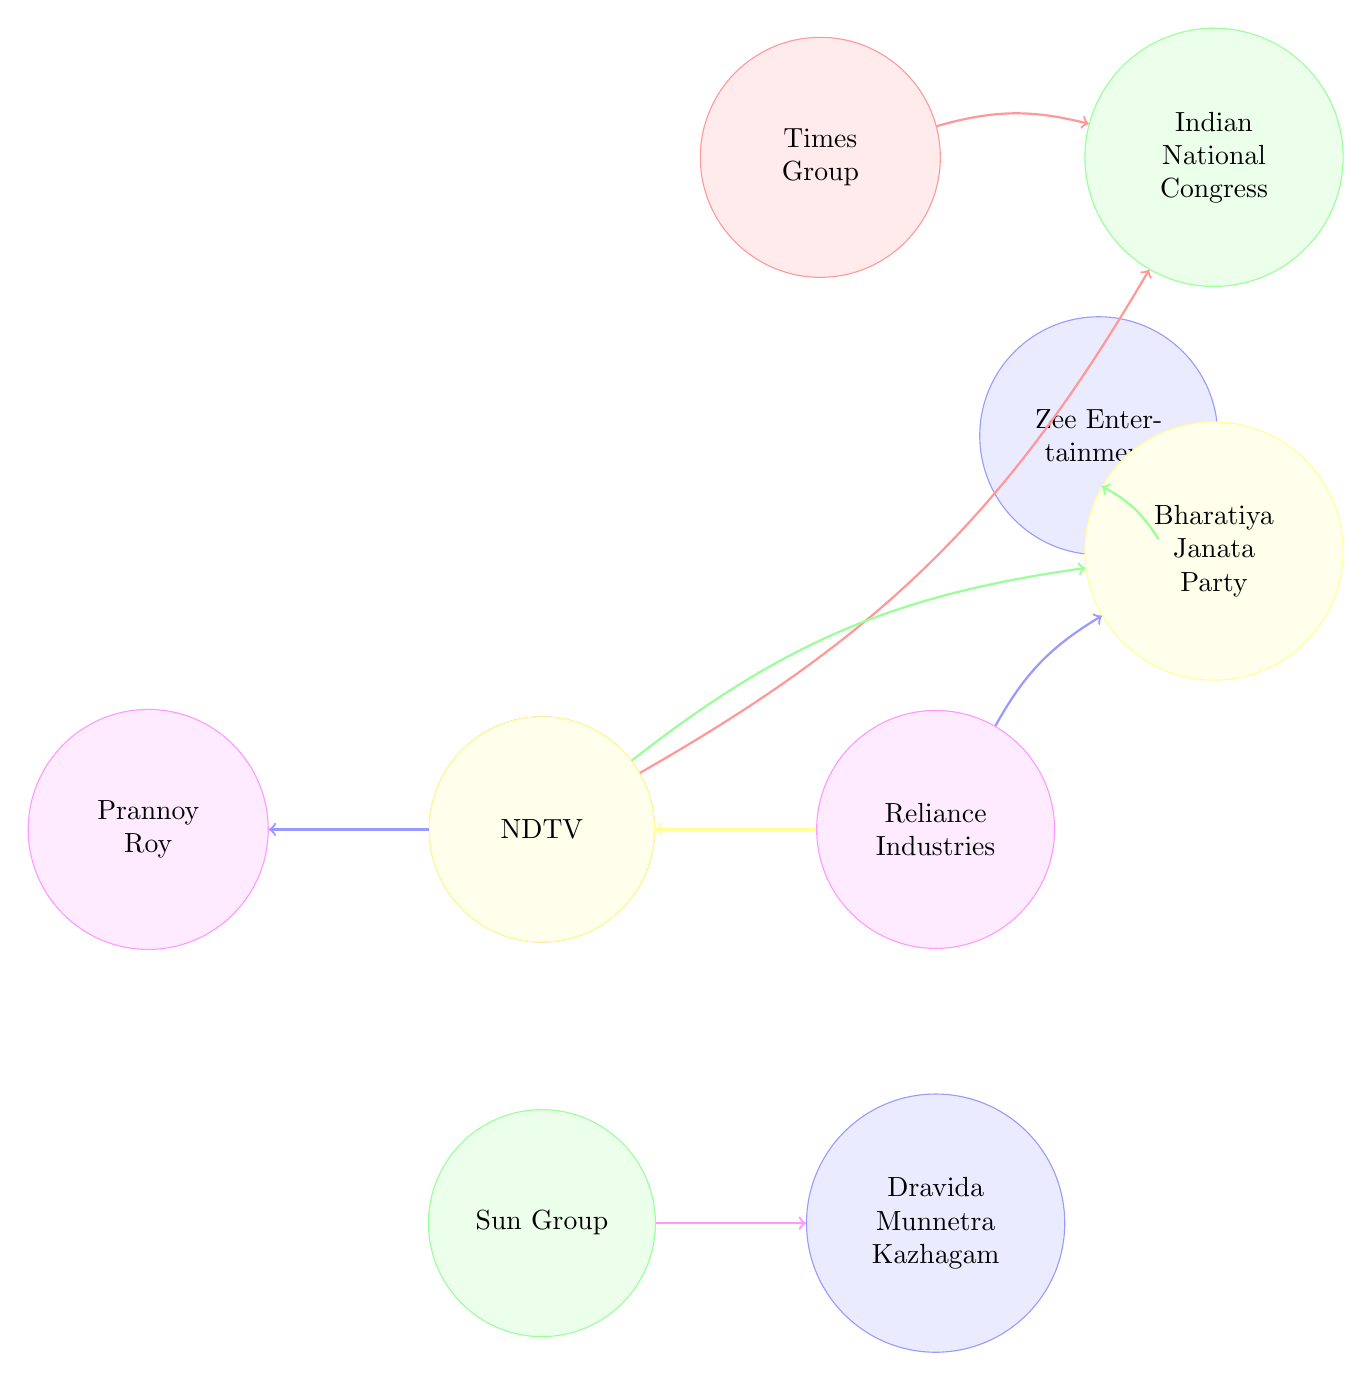What are the total number of nodes in the diagram? The diagram contains ten nodes: Times Group, Indian National Congress, Zee Entertainment, Bharatiya Janata Party, Reliance Industries, Network18, Sun Group, Dravida Munnetra Kazhagam, NDTV, and Prannoy Roy.
Answer: 10 Which media house is linked to the Indian National Congress? The diagram shows that Times Group and NDTV are linked to the Indian National Congress. The arrows indicate these relationships explicitly.
Answer: Times Group, NDTV Which political party is connected to Zee Entertainment? The diagram shows a direct connection (an arrow) from Zee Entertainment to Bharatiya Janata Party.
Answer: Bharatiya Janata Party How many connections does Reliance Industries have? Reliance Industries has three connections in the diagram: one to Bharatiya Janata Party, one to Network18, and another to itself in terms of influence.
Answer: 2 Who is directly connected to NDTV? NDTV has direct connections to Indian National Congress and Prannoy Roy. By observing the outgoing arrows from the NDTV node, we can determine these connections.
Answer: Indian National Congress, Prannoy Roy Which media houses are affiliated with the Bharatiya Janata Party? The connections show that Zee Entertainment, Reliance Industries, and Network18 are linked to Bharatiya Janata Party. This is seen through the arrows pointing from these media houses to the political party.
Answer: Zee Entertainment, Reliance Industries, Network18 Which party does Sun Group influence? The diagram displays an arrow from Sun Group to Dravida Munnetra Kazhagam, indicating influence or connection, so that is the answer.
Answer: Dravida Munnetra Kazhagam Is there any overlap between media houses affiliated with different political parties? Yes, both Times Group and NDTV are affiliated with the Indian National Congress, while Network18 and Reliance Industries are linked to the Bharatiya Janata Party, showcasing this overlap through their connections.
Answer: Yes What type of relationship exists between NDTV and Prannoy Roy? There is a direct connection depicted by an arrow linking NDTV to Prannoy Roy, indicating a personal or direct influence as an owner or key figure in the organization.
Answer: Direct relationship 